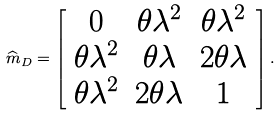<formula> <loc_0><loc_0><loc_500><loc_500>\widehat { m } _ { D } = \left [ \begin{array} { c c c } 0 & \theta \lambda ^ { 2 } & \theta \lambda ^ { 2 } \\ \theta \lambda ^ { 2 } & \theta \lambda & 2 \theta \lambda \\ \theta \lambda ^ { 2 } & 2 \theta \lambda & 1 \end{array} \right ] .</formula> 